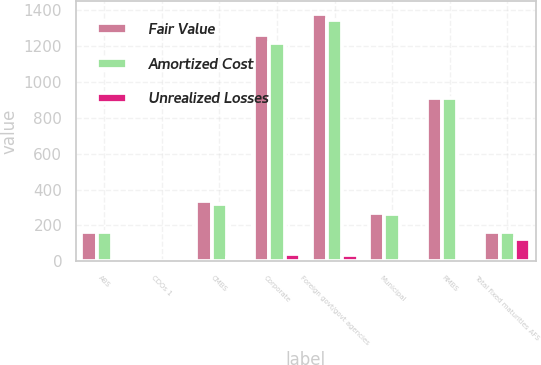<chart> <loc_0><loc_0><loc_500><loc_500><stacked_bar_chart><ecel><fcel>ABS<fcel>CDOs 1<fcel>CMBS<fcel>Corporate<fcel>Foreign govt/govt agencies<fcel>Municipal<fcel>RMBS<fcel>Total fixed maturities AFS<nl><fcel>Fair Value<fcel>163<fcel>5<fcel>339<fcel>1261<fcel>1380<fcel>271<fcel>910<fcel>162<nl><fcel>Amortized Cost<fcel>161<fcel>4<fcel>322<fcel>1218<fcel>1343<fcel>265<fcel>908<fcel>162<nl><fcel>Unrealized Losses<fcel>2<fcel>1<fcel>17<fcel>43<fcel>37<fcel>6<fcel>2<fcel>124<nl></chart> 